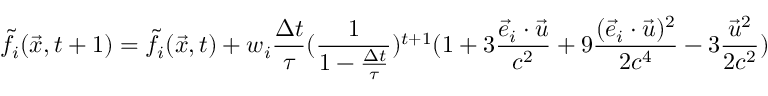<formula> <loc_0><loc_0><loc_500><loc_500>\tilde { f } _ { i } ( \vec { x } , t + 1 ) = \tilde { f } _ { i } ( \vec { x } , t ) + w _ { i } \frac { \Delta t } { \tau } ( \frac { 1 } { 1 - \frac { \Delta t } { \tau } } ) ^ { t + 1 } ( 1 + 3 \frac { \ V e c { e } _ { i } \cdot \ V e c { u } } { c ^ { 2 } } + 9 \frac { ( \ V e c { e } _ { i } \cdot \ V e c { u } ) ^ { 2 } } { 2 c ^ { 4 } } - 3 \frac { \ V e c { u } ^ { 2 } } { 2 c ^ { 2 } } )</formula> 